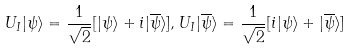Convert formula to latex. <formula><loc_0><loc_0><loc_500><loc_500>U _ { I } | \psi \rangle = \frac { 1 } { \sqrt { 2 } } [ | \psi \rangle + i | { \overline { \psi } } \rangle ] , U _ { I } | { \overline { \psi } } \rangle = \frac { 1 } { \sqrt { 2 } } [ i | \psi \rangle + | { \overline { \psi } } \rangle ]</formula> 